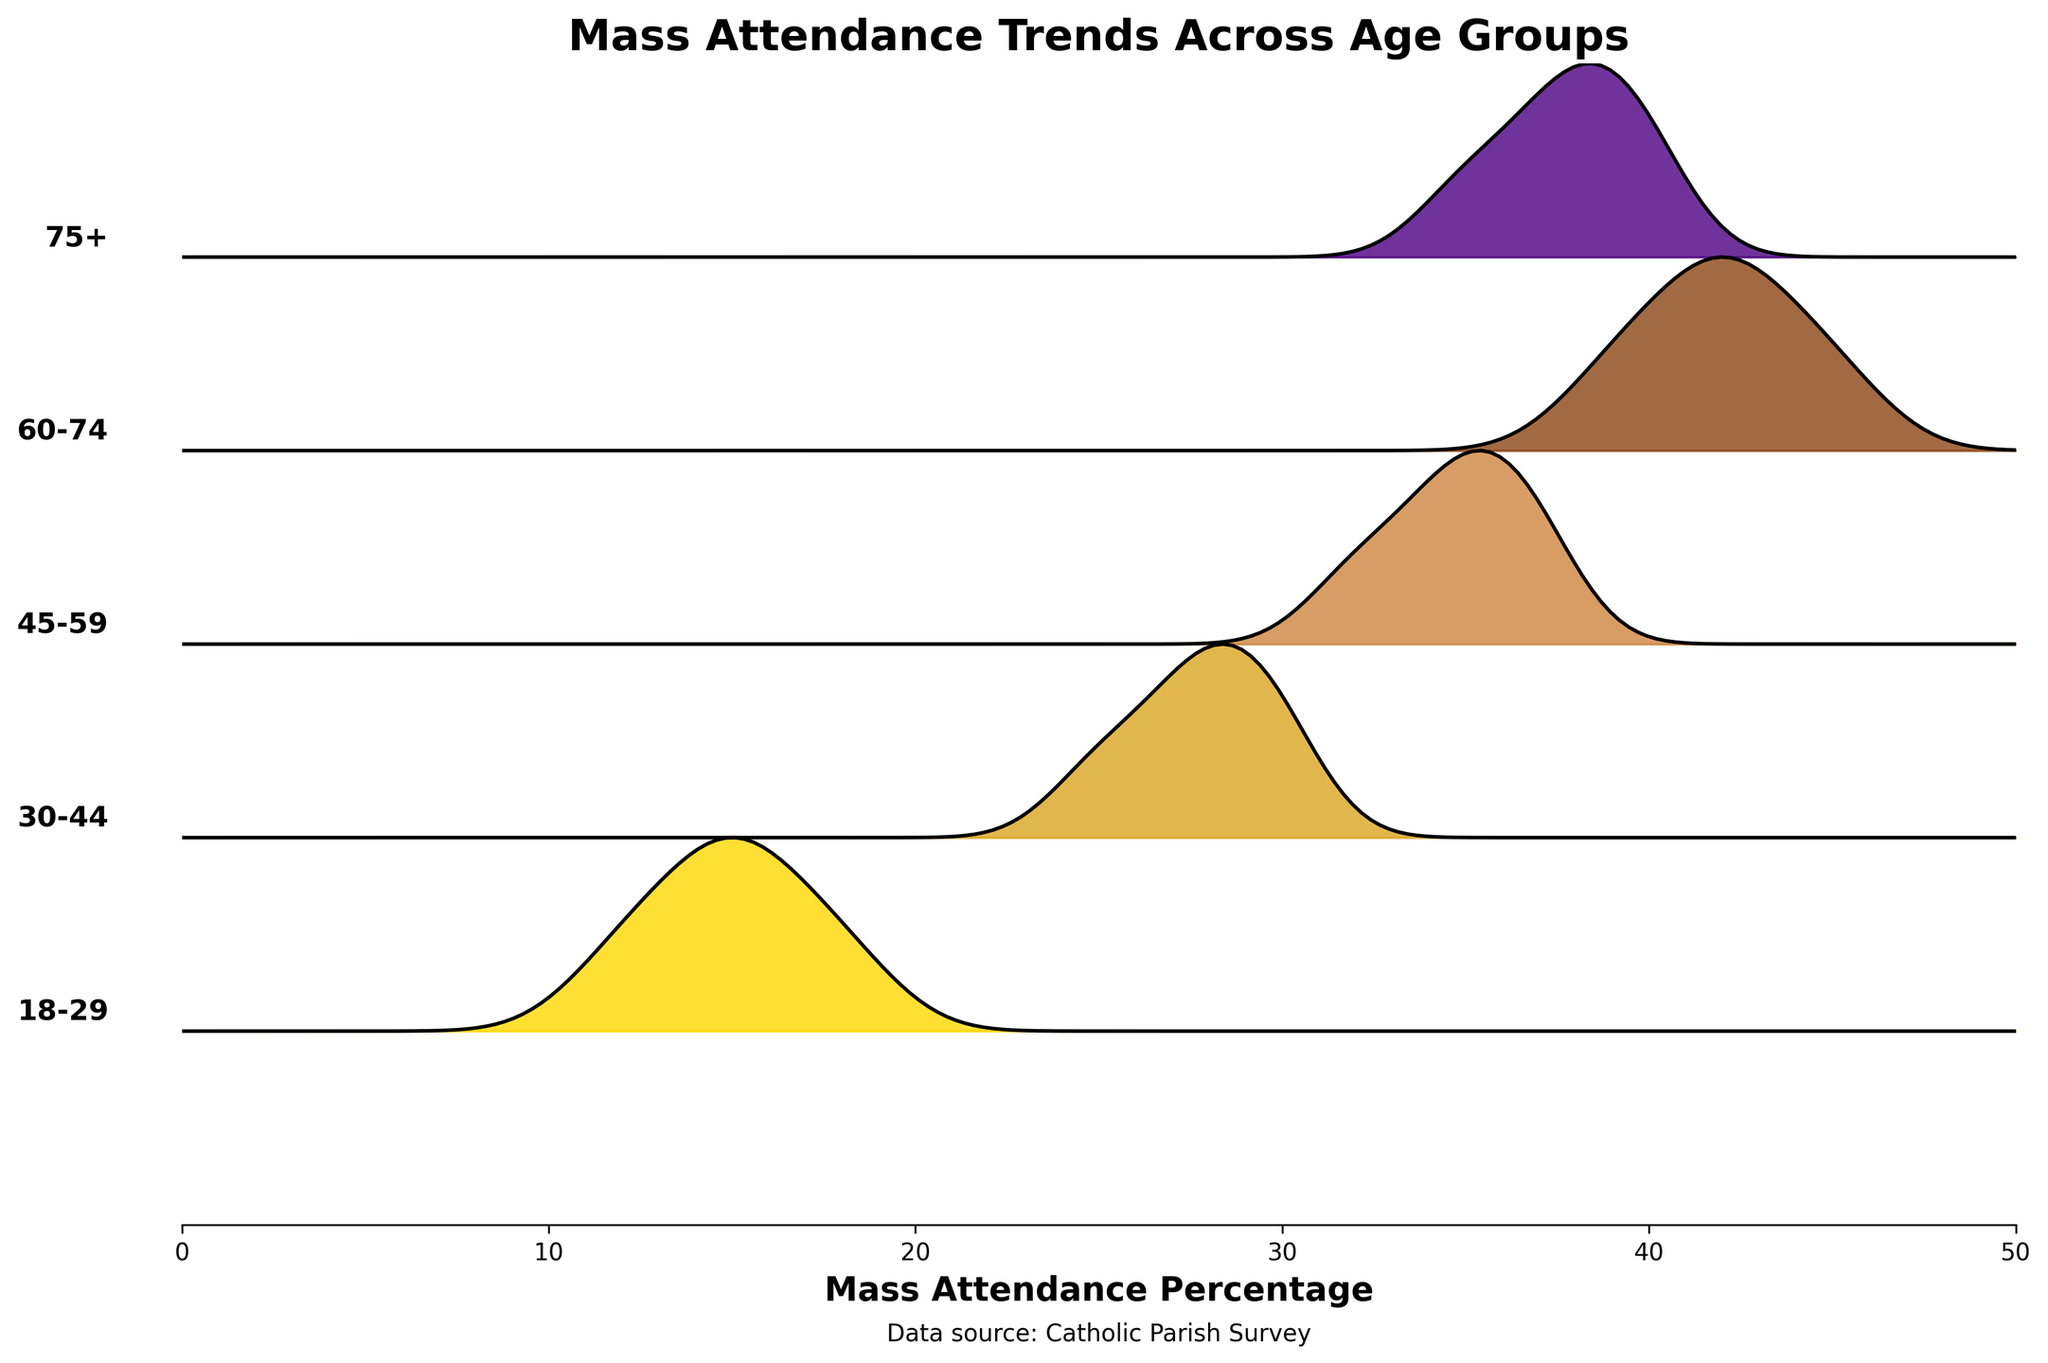What's the title of the plot? The title can be found at the top of the figure.
Answer: "Mass Attendance Trends Across Age Groups" What is the x-axis label in the plot? The x-axis label is the text shown along the horizontal axis of the plot.
Answer: "Mass Attendance Percentage" How many age groups are displayed in the plot? The number of ridgelines in the plot corresponds to the number of different age groups. By counting them, we see there are 5 ridgelines, each representing a different age group.
Answer: 5 Which age group has the peak attendance percentage according to the plot? Find the age group whose ridgeline extends furthest to the right. This likely indicates the highest attendance percentage.
Answer: 60-74 How does the attendance percentage of the 18-29 age group compare to the 30-44 age group? Check the range of values covered by the ridgelines of both age groups and compare their maximum attendance percentages.
Answer: The 30-44 age group's ridgeline extends further to the right compared to the 18-29 age group, indicating higher attendance Which age group has a higher attendance percentage, 45-59 or 75+? Compare the positions of the ridgelines for the 45-59 and 75+ age groups. The age group with the ridgeline extending further to the right has a higher attendance percentage.
Answer: 45-59 What color represents the age group 30-44? Identify the color assigned to the ridgeline labeled "30-44". In the custom color map used, each age group has a unique color.
Answer: Golden olive (second color in the custom color map) What is the general trend of mass attendance as age increases? Examine how the ridgelines shift from left to right as the age groups progress from younger to older.
Answer: Attendance tends to increase with age Which parish has the highest mass attendance percentage for the age group 60-74? Locate the peak of the ridgeline for the 60-74 age group and note its highest value, then match this value to the corresponding parish in the data.
Answer: St. Joseph's (45%) What is the approximate attendance percentage at the main peak for the age group 75+? Look at the peak of the ridgeline for the age group 75+ and estimate its position on the x-axis.
Answer: Around 40% 